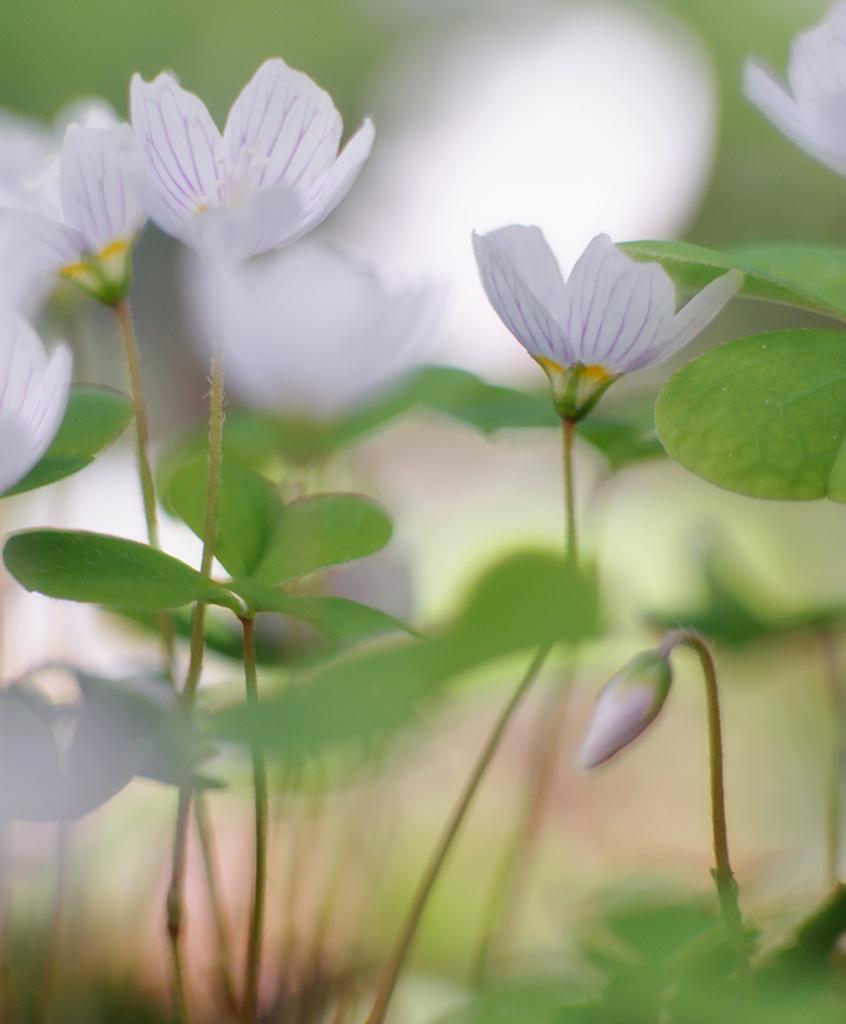Describe this image in one or two sentences. In this image there are white flowers and leaves. 